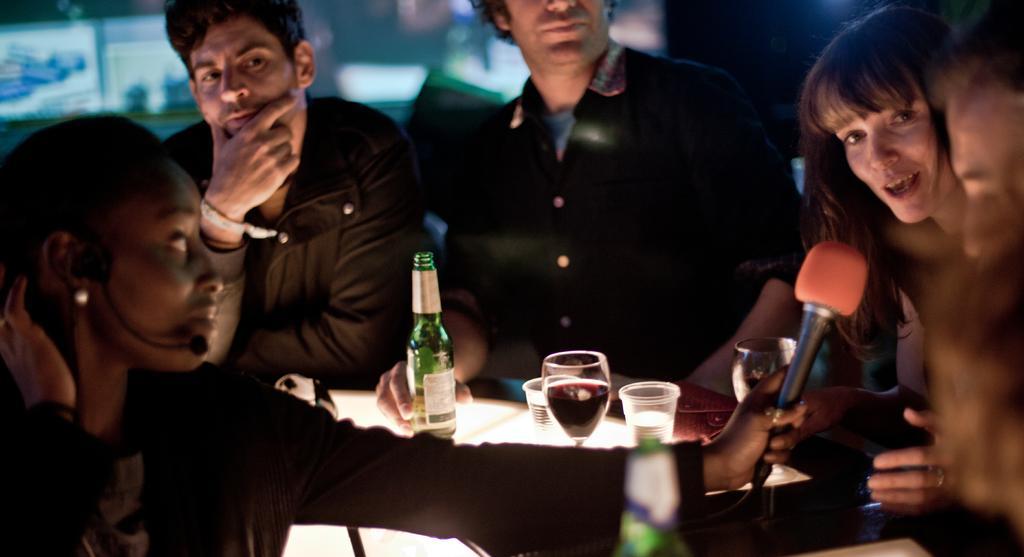Please provide a concise description of this image. In this picture we can see three men and two woman they are standing and where woman is holding mic with her hand and other woman is talking and in front of them on table we have bottle, glass with drink in it and in background it is screen. 